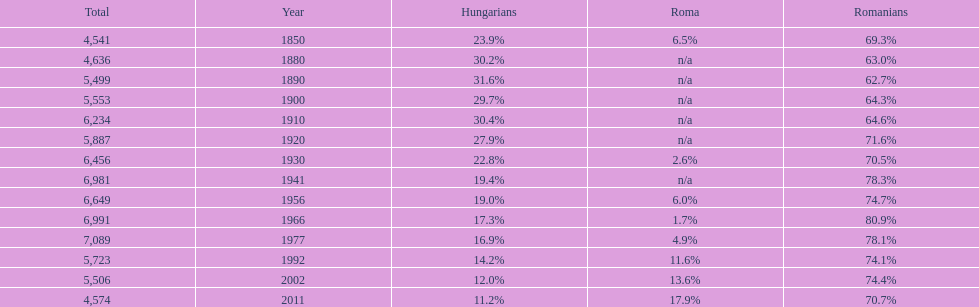Which year had the top percentage in romanian population? 1966. 